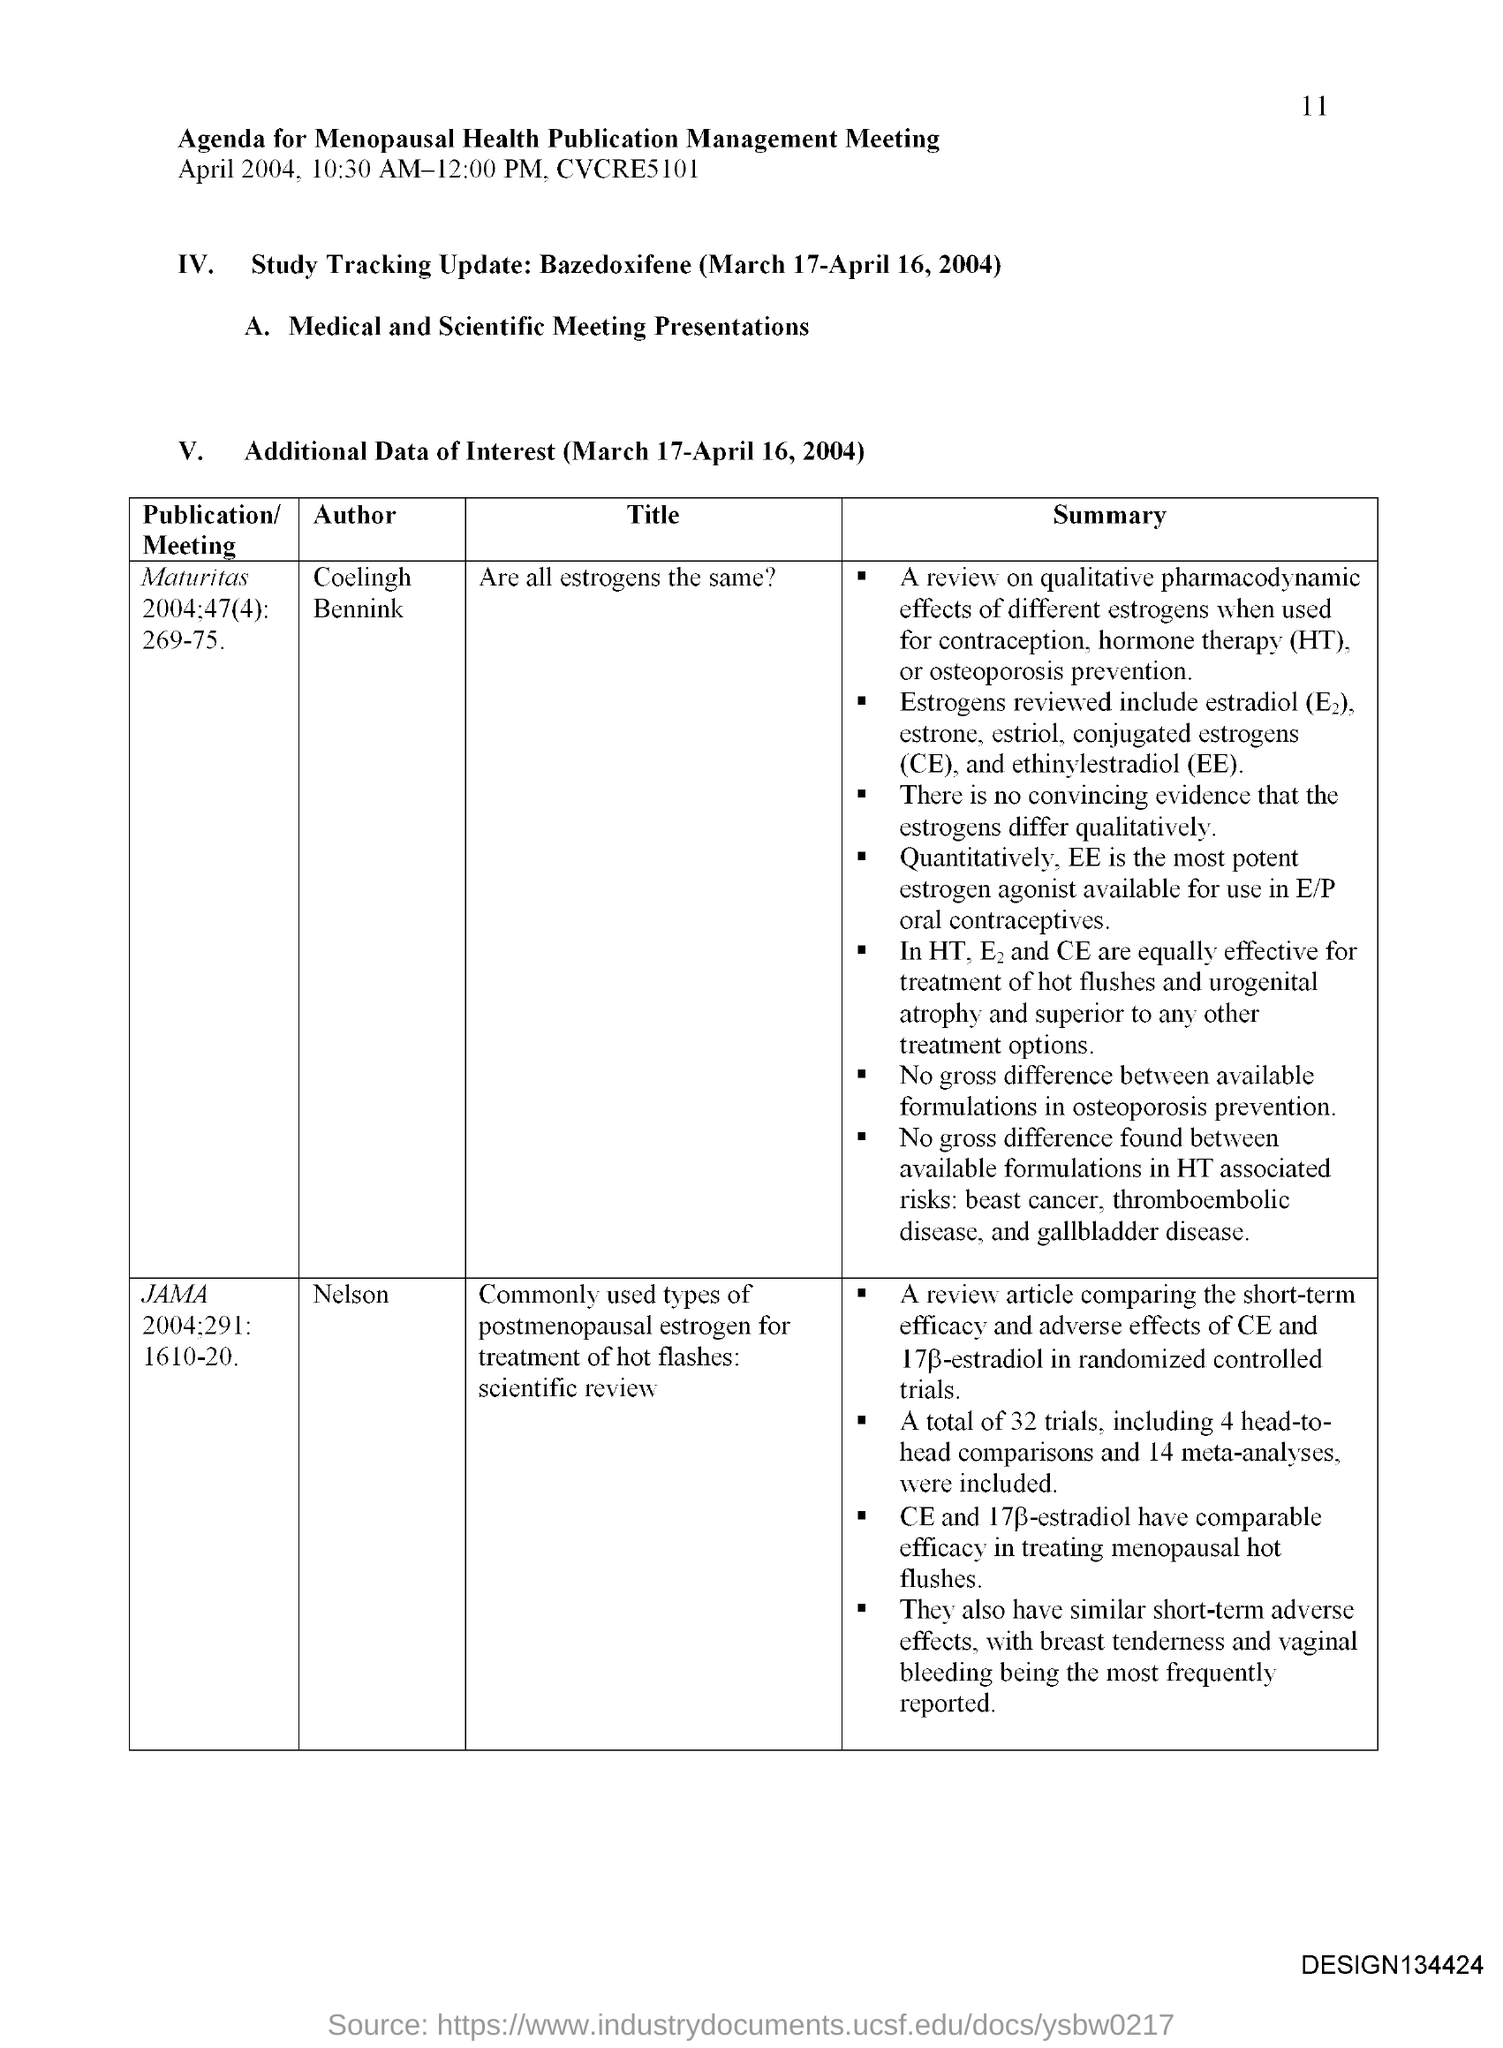What is the fullform of HT?
Provide a succinct answer. Hormone therapy. What is the abbreviation for conjugated estrogens?
Your response must be concise. CE. What is the fullform of EE?
Offer a terse response. Ethinylestradiol. 